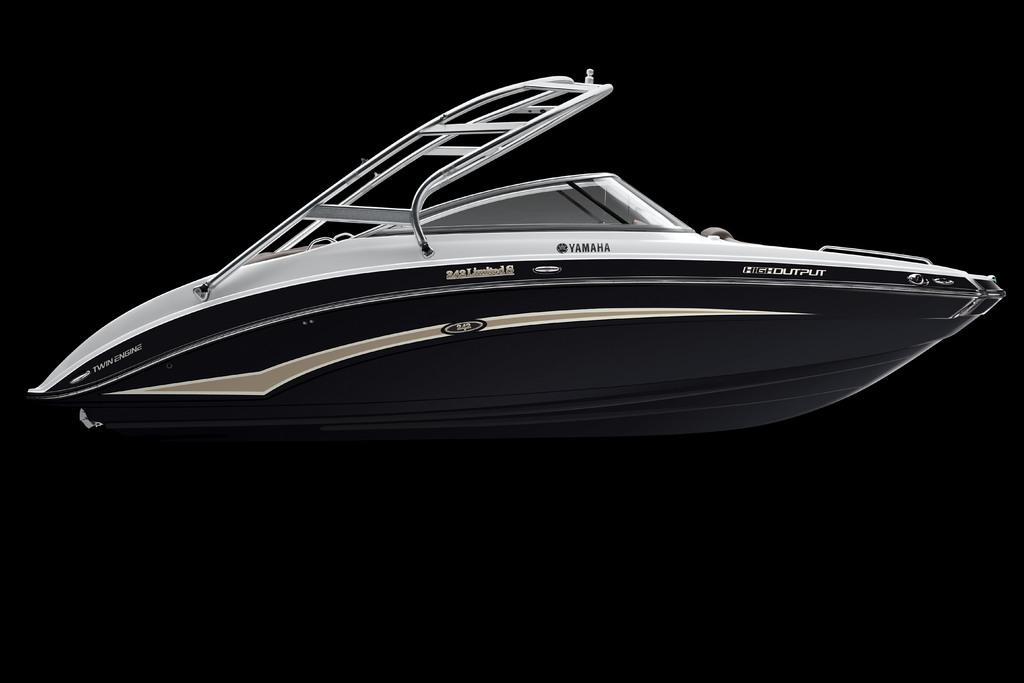<image>
Describe the image concisely. A sleek looking boat that has High Output labeled on it's side. 